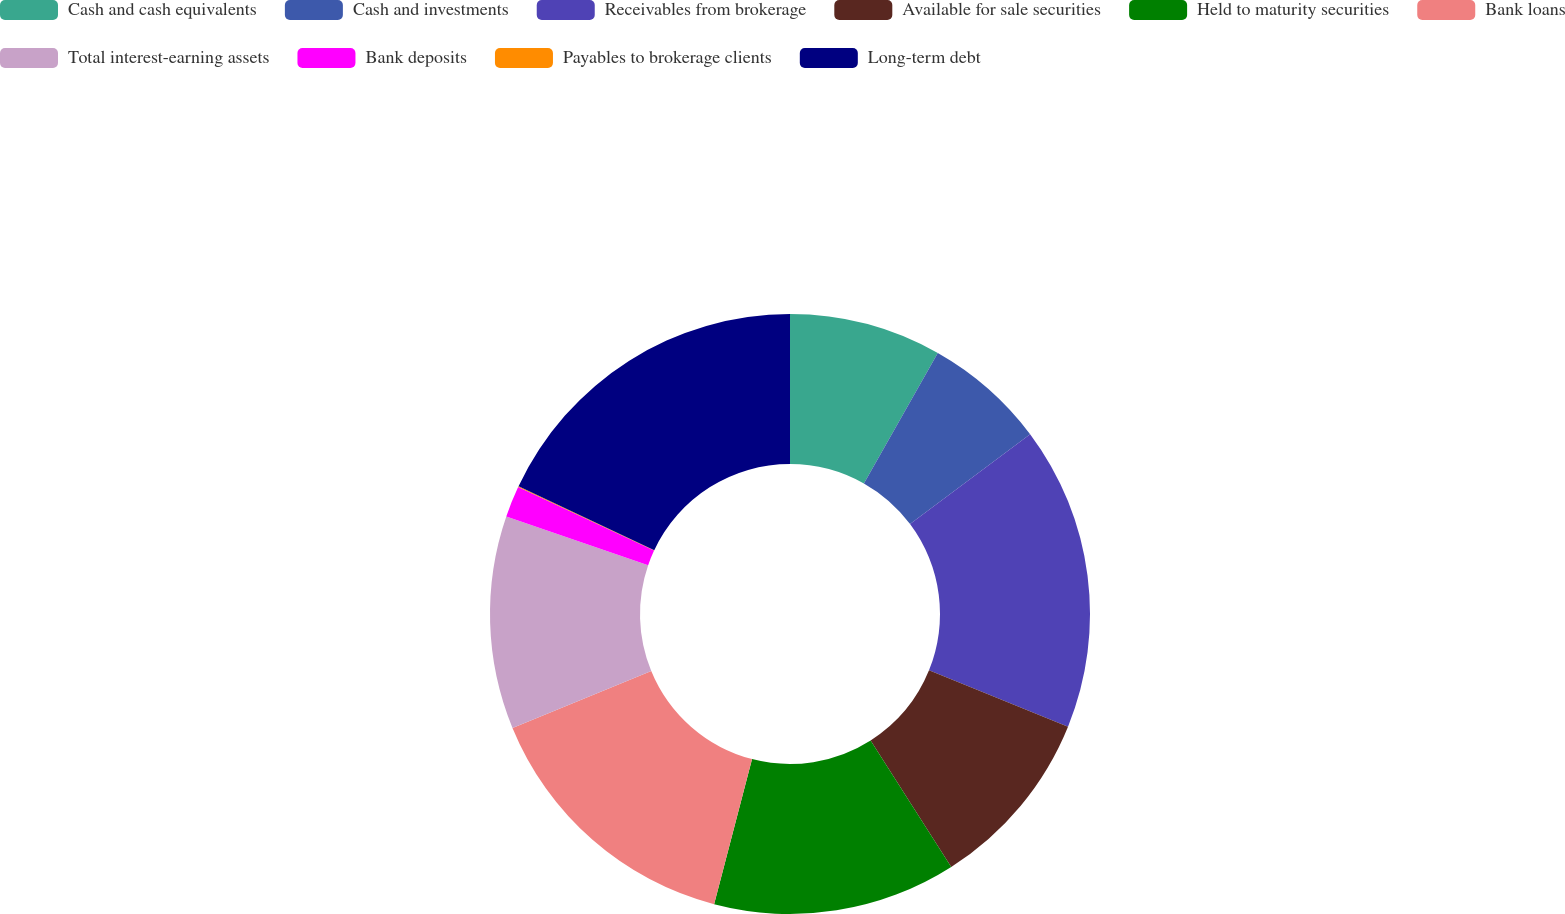<chart> <loc_0><loc_0><loc_500><loc_500><pie_chart><fcel>Cash and cash equivalents<fcel>Cash and investments<fcel>Receivables from brokerage<fcel>Available for sale securities<fcel>Held to maturity securities<fcel>Bank loans<fcel>Total interest-earning assets<fcel>Bank deposits<fcel>Payables to brokerage clients<fcel>Long-term debt<nl><fcel>8.2%<fcel>6.57%<fcel>16.36%<fcel>9.84%<fcel>13.1%<fcel>14.73%<fcel>11.47%<fcel>1.68%<fcel>0.05%<fcel>18.0%<nl></chart> 